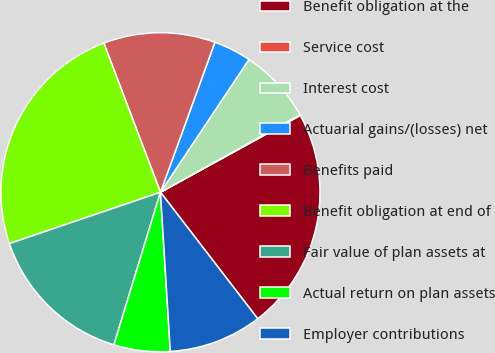Convert chart to OTSL. <chart><loc_0><loc_0><loc_500><loc_500><pie_chart><fcel>Benefit obligation at the<fcel>Service cost<fcel>Interest cost<fcel>Actuarial gains/(losses) net<fcel>Benefits paid<fcel>Benefit obligation at end of<fcel>Fair value of plan assets at<fcel>Actual return on plan assets<fcel>Employer contributions<nl><fcel>22.56%<fcel>0.08%<fcel>7.57%<fcel>3.82%<fcel>11.32%<fcel>24.44%<fcel>15.07%<fcel>5.7%<fcel>9.45%<nl></chart> 